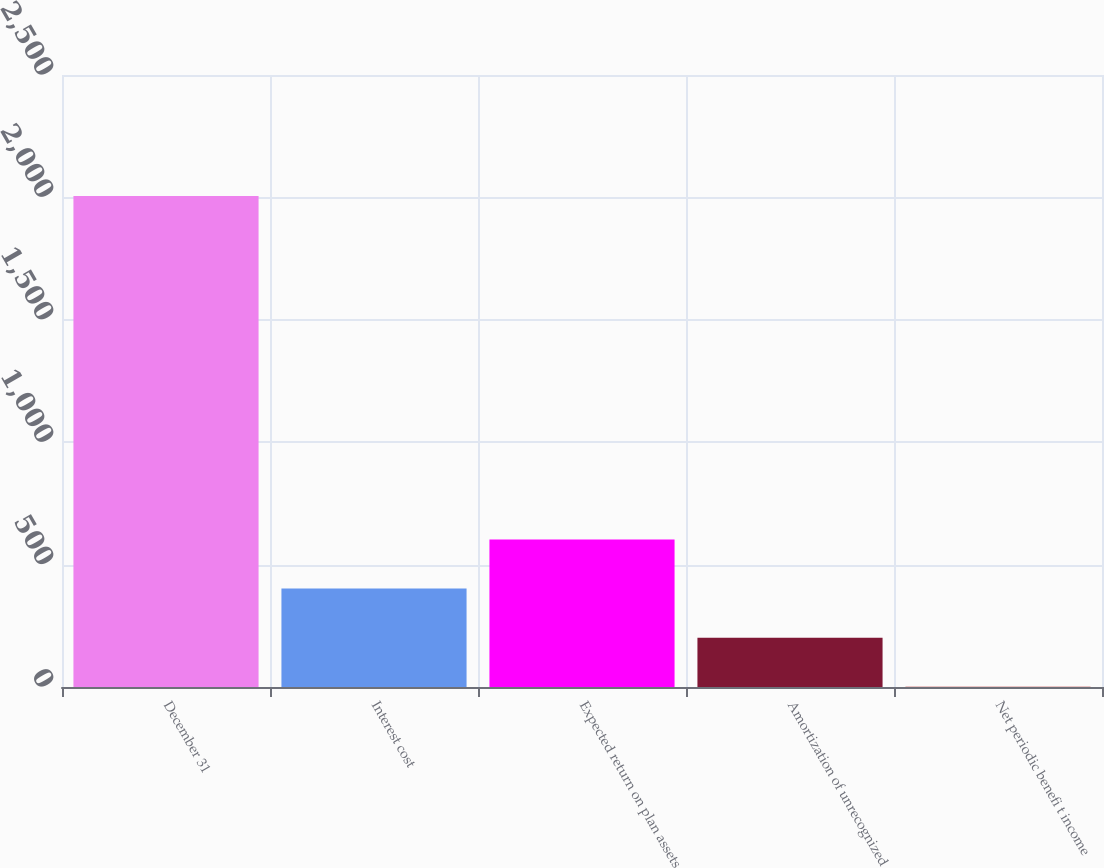Convert chart to OTSL. <chart><loc_0><loc_0><loc_500><loc_500><bar_chart><fcel>December 31<fcel>Interest cost<fcel>Expected return on plan assets<fcel>Amortization of unrecognized<fcel>Net periodic benefi t income<nl><fcel>2006<fcel>401.92<fcel>602.43<fcel>201.41<fcel>0.9<nl></chart> 